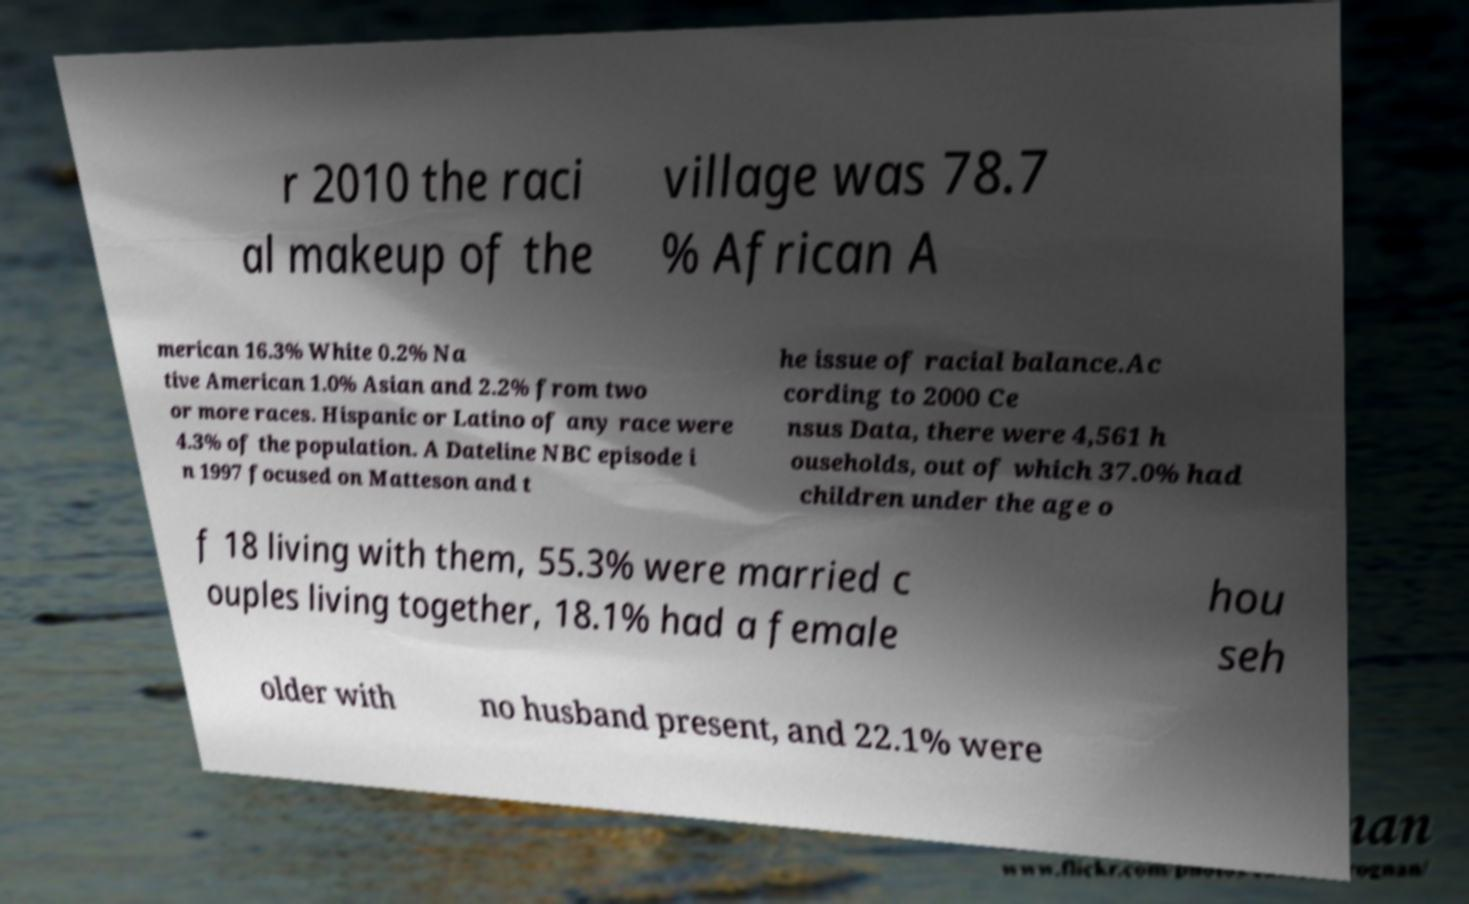What messages or text are displayed in this image? I need them in a readable, typed format. r 2010 the raci al makeup of the village was 78.7 % African A merican 16.3% White 0.2% Na tive American 1.0% Asian and 2.2% from two or more races. Hispanic or Latino of any race were 4.3% of the population. A Dateline NBC episode i n 1997 focused on Matteson and t he issue of racial balance.Ac cording to 2000 Ce nsus Data, there were 4,561 h ouseholds, out of which 37.0% had children under the age o f 18 living with them, 55.3% were married c ouples living together, 18.1% had a female hou seh older with no husband present, and 22.1% were 